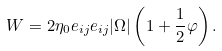<formula> <loc_0><loc_0><loc_500><loc_500>W = 2 \eta _ { 0 } e _ { i j } e _ { i j } | \Omega | \left ( 1 + \frac { 1 } { 2 } \varphi \right ) .</formula> 